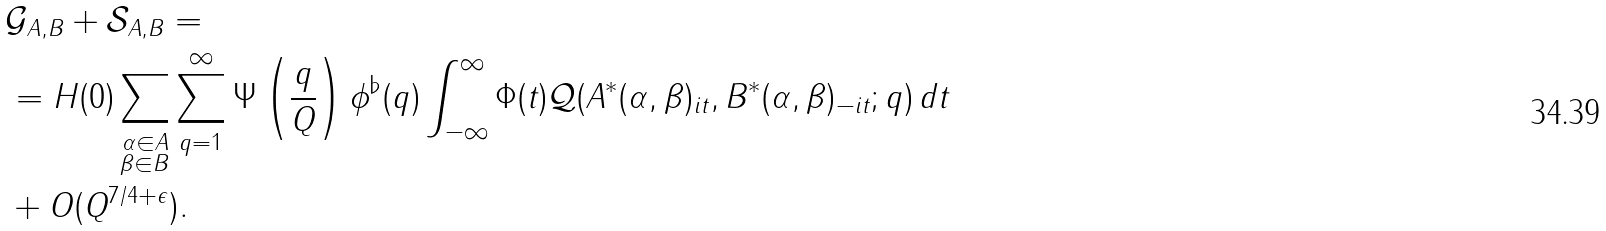Convert formula to latex. <formula><loc_0><loc_0><loc_500><loc_500>& \mathcal { G } _ { A , B } + \mathcal { S } _ { A , B } = \\ & = H ( 0 ) \sum _ { \substack { \alpha \in A \\ \beta \in B } } \sum _ { q = 1 } ^ { \infty } \Psi \left ( \frac { q } { Q } \right ) \phi ^ { \flat } ( q ) \int _ { - \infty } ^ { \infty } \Phi ( t ) \mathcal { Q } ( A ^ { * } ( \alpha , \beta ) _ { i t } , B ^ { * } ( \alpha , \beta ) _ { - i t } ; q ) \, d t \\ & + O ( Q ^ { 7 / 4 + \epsilon } ) .</formula> 